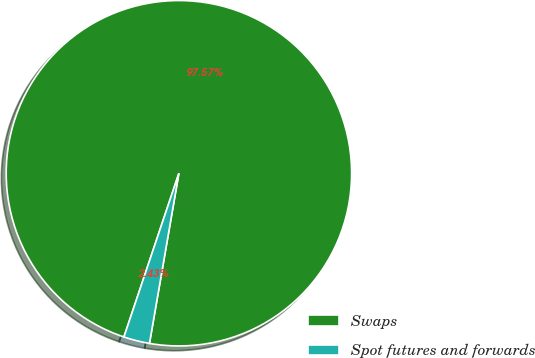Convert chart to OTSL. <chart><loc_0><loc_0><loc_500><loc_500><pie_chart><fcel>Swaps<fcel>Spot futures and forwards<nl><fcel>97.57%<fcel>2.43%<nl></chart> 